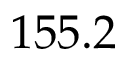Convert formula to latex. <formula><loc_0><loc_0><loc_500><loc_500>1 5 5 . 2</formula> 